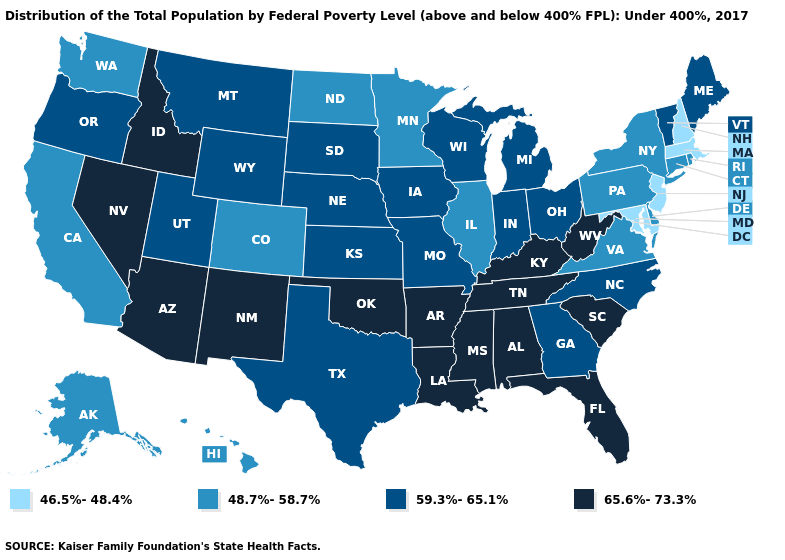What is the highest value in the USA?
Short answer required. 65.6%-73.3%. Name the states that have a value in the range 46.5%-48.4%?
Give a very brief answer. Maryland, Massachusetts, New Hampshire, New Jersey. Does Kansas have a lower value than California?
Short answer required. No. Which states have the lowest value in the MidWest?
Be succinct. Illinois, Minnesota, North Dakota. What is the lowest value in states that border Nevada?
Quick response, please. 48.7%-58.7%. Is the legend a continuous bar?
Give a very brief answer. No. Name the states that have a value in the range 48.7%-58.7%?
Keep it brief. Alaska, California, Colorado, Connecticut, Delaware, Hawaii, Illinois, Minnesota, New York, North Dakota, Pennsylvania, Rhode Island, Virginia, Washington. What is the highest value in the USA?
Keep it brief. 65.6%-73.3%. Name the states that have a value in the range 59.3%-65.1%?
Write a very short answer. Georgia, Indiana, Iowa, Kansas, Maine, Michigan, Missouri, Montana, Nebraska, North Carolina, Ohio, Oregon, South Dakota, Texas, Utah, Vermont, Wisconsin, Wyoming. Does Massachusetts have the highest value in the Northeast?
Concise answer only. No. Which states hav the highest value in the South?
Answer briefly. Alabama, Arkansas, Florida, Kentucky, Louisiana, Mississippi, Oklahoma, South Carolina, Tennessee, West Virginia. Does Massachusetts have a lower value than New Hampshire?
Answer briefly. No. Which states have the lowest value in the MidWest?
Short answer required. Illinois, Minnesota, North Dakota. What is the value of West Virginia?
Answer briefly. 65.6%-73.3%. What is the lowest value in states that border Kansas?
Give a very brief answer. 48.7%-58.7%. 